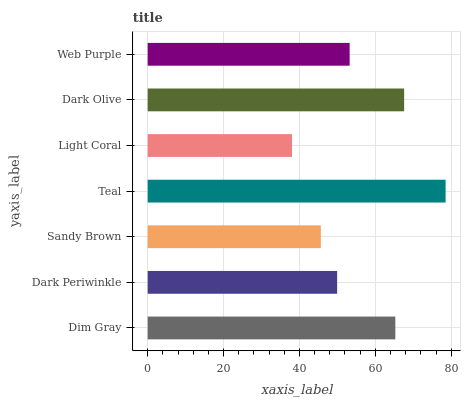Is Light Coral the minimum?
Answer yes or no. Yes. Is Teal the maximum?
Answer yes or no. Yes. Is Dark Periwinkle the minimum?
Answer yes or no. No. Is Dark Periwinkle the maximum?
Answer yes or no. No. Is Dim Gray greater than Dark Periwinkle?
Answer yes or no. Yes. Is Dark Periwinkle less than Dim Gray?
Answer yes or no. Yes. Is Dark Periwinkle greater than Dim Gray?
Answer yes or no. No. Is Dim Gray less than Dark Periwinkle?
Answer yes or no. No. Is Web Purple the high median?
Answer yes or no. Yes. Is Web Purple the low median?
Answer yes or no. Yes. Is Sandy Brown the high median?
Answer yes or no. No. Is Sandy Brown the low median?
Answer yes or no. No. 